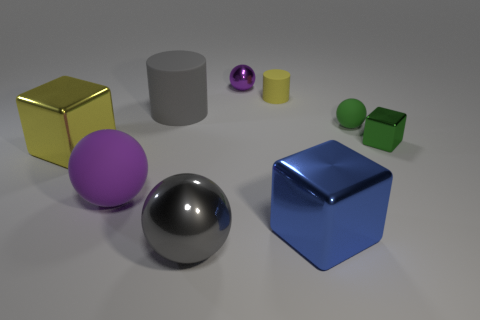Subtract all gray spheres. How many spheres are left? 3 Subtract all tiny purple spheres. How many spheres are left? 3 Add 1 green metal cubes. How many objects exist? 10 Subtract all red spheres. Subtract all yellow cubes. How many spheres are left? 4 Subtract all spheres. How many objects are left? 5 Subtract all big gray matte objects. Subtract all purple shiny balls. How many objects are left? 7 Add 9 yellow cylinders. How many yellow cylinders are left? 10 Add 8 small purple spheres. How many small purple spheres exist? 9 Subtract 1 yellow cylinders. How many objects are left? 8 